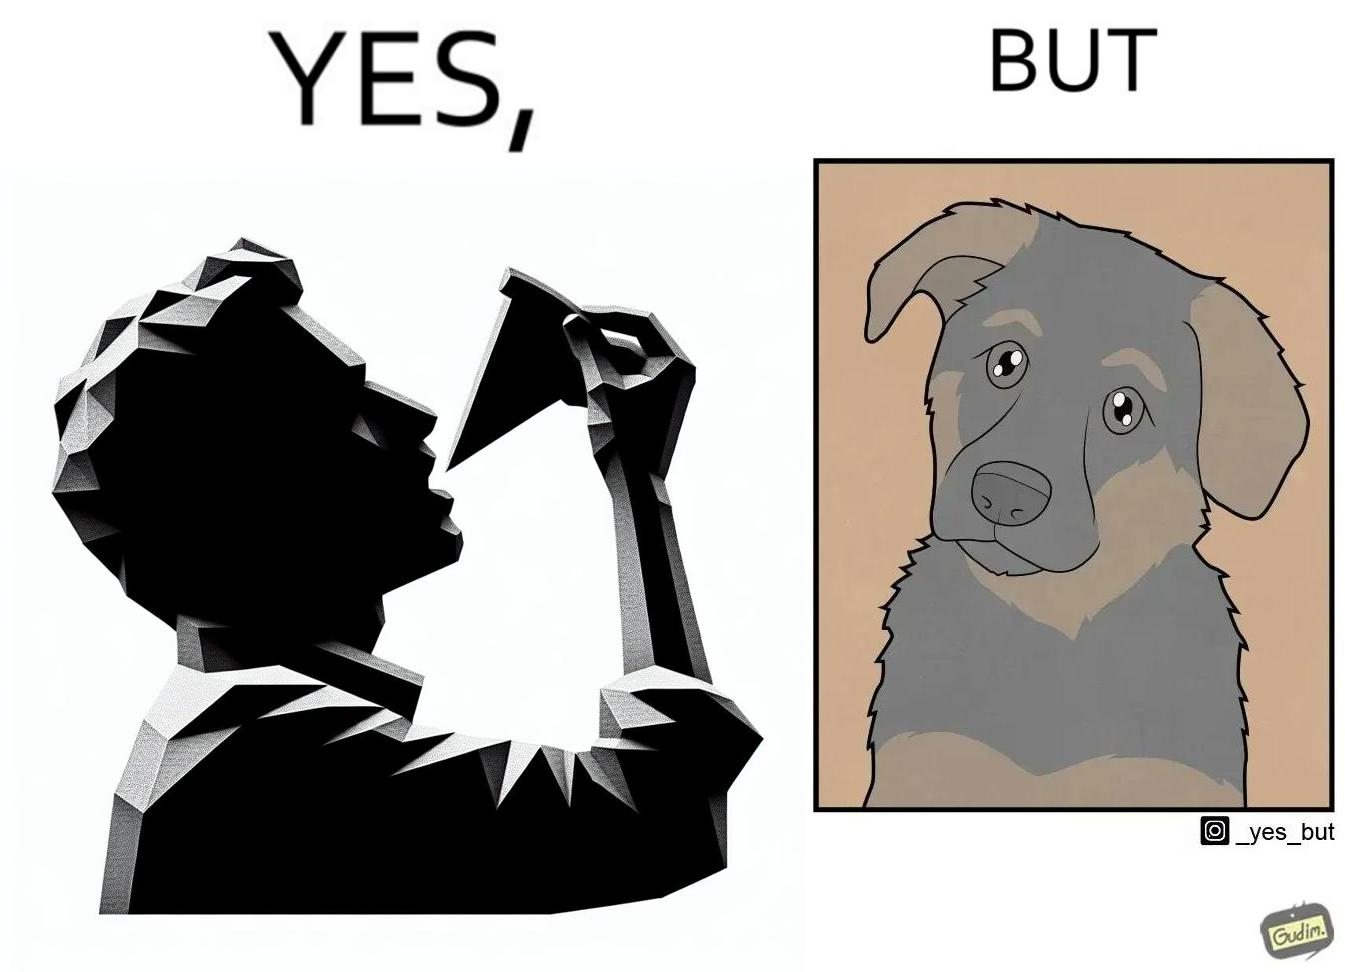Is there satirical content in this image? Yes, this image is satirical. 